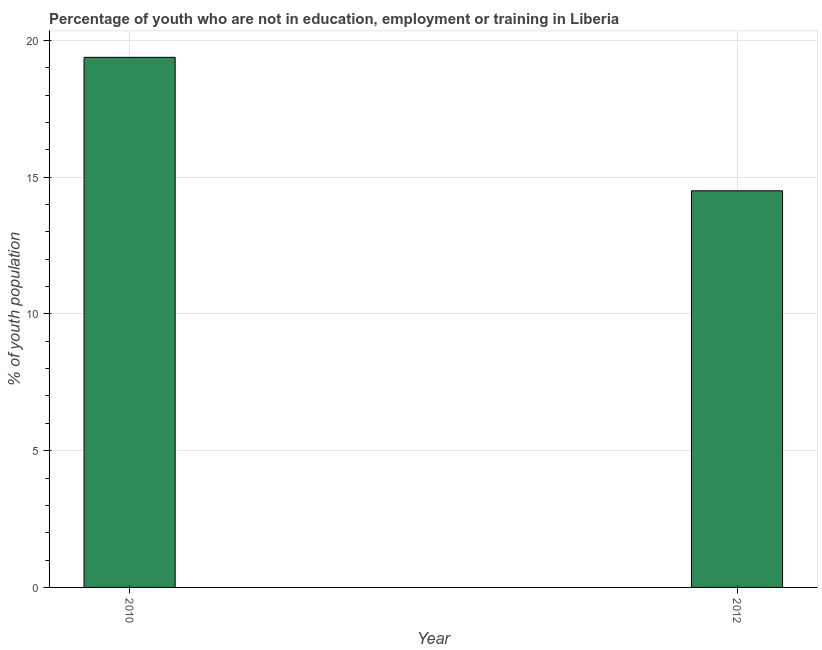Does the graph contain grids?
Offer a terse response. Yes. What is the title of the graph?
Keep it short and to the point. Percentage of youth who are not in education, employment or training in Liberia. What is the label or title of the Y-axis?
Your answer should be very brief. % of youth population. What is the unemployed youth population in 2012?
Offer a very short reply. 14.5. Across all years, what is the maximum unemployed youth population?
Give a very brief answer. 19.38. Across all years, what is the minimum unemployed youth population?
Keep it short and to the point. 14.5. In which year was the unemployed youth population maximum?
Your answer should be very brief. 2010. What is the sum of the unemployed youth population?
Keep it short and to the point. 33.88. What is the difference between the unemployed youth population in 2010 and 2012?
Keep it short and to the point. 4.88. What is the average unemployed youth population per year?
Keep it short and to the point. 16.94. What is the median unemployed youth population?
Your response must be concise. 16.94. In how many years, is the unemployed youth population greater than 8 %?
Offer a very short reply. 2. What is the ratio of the unemployed youth population in 2010 to that in 2012?
Your answer should be compact. 1.34. Is the unemployed youth population in 2010 less than that in 2012?
Ensure brevity in your answer.  No. How many bars are there?
Provide a succinct answer. 2. Are all the bars in the graph horizontal?
Your answer should be compact. No. How many years are there in the graph?
Provide a short and direct response. 2. What is the difference between two consecutive major ticks on the Y-axis?
Keep it short and to the point. 5. Are the values on the major ticks of Y-axis written in scientific E-notation?
Your response must be concise. No. What is the % of youth population of 2010?
Ensure brevity in your answer.  19.38. What is the % of youth population of 2012?
Make the answer very short. 14.5. What is the difference between the % of youth population in 2010 and 2012?
Provide a short and direct response. 4.88. What is the ratio of the % of youth population in 2010 to that in 2012?
Your answer should be compact. 1.34. 